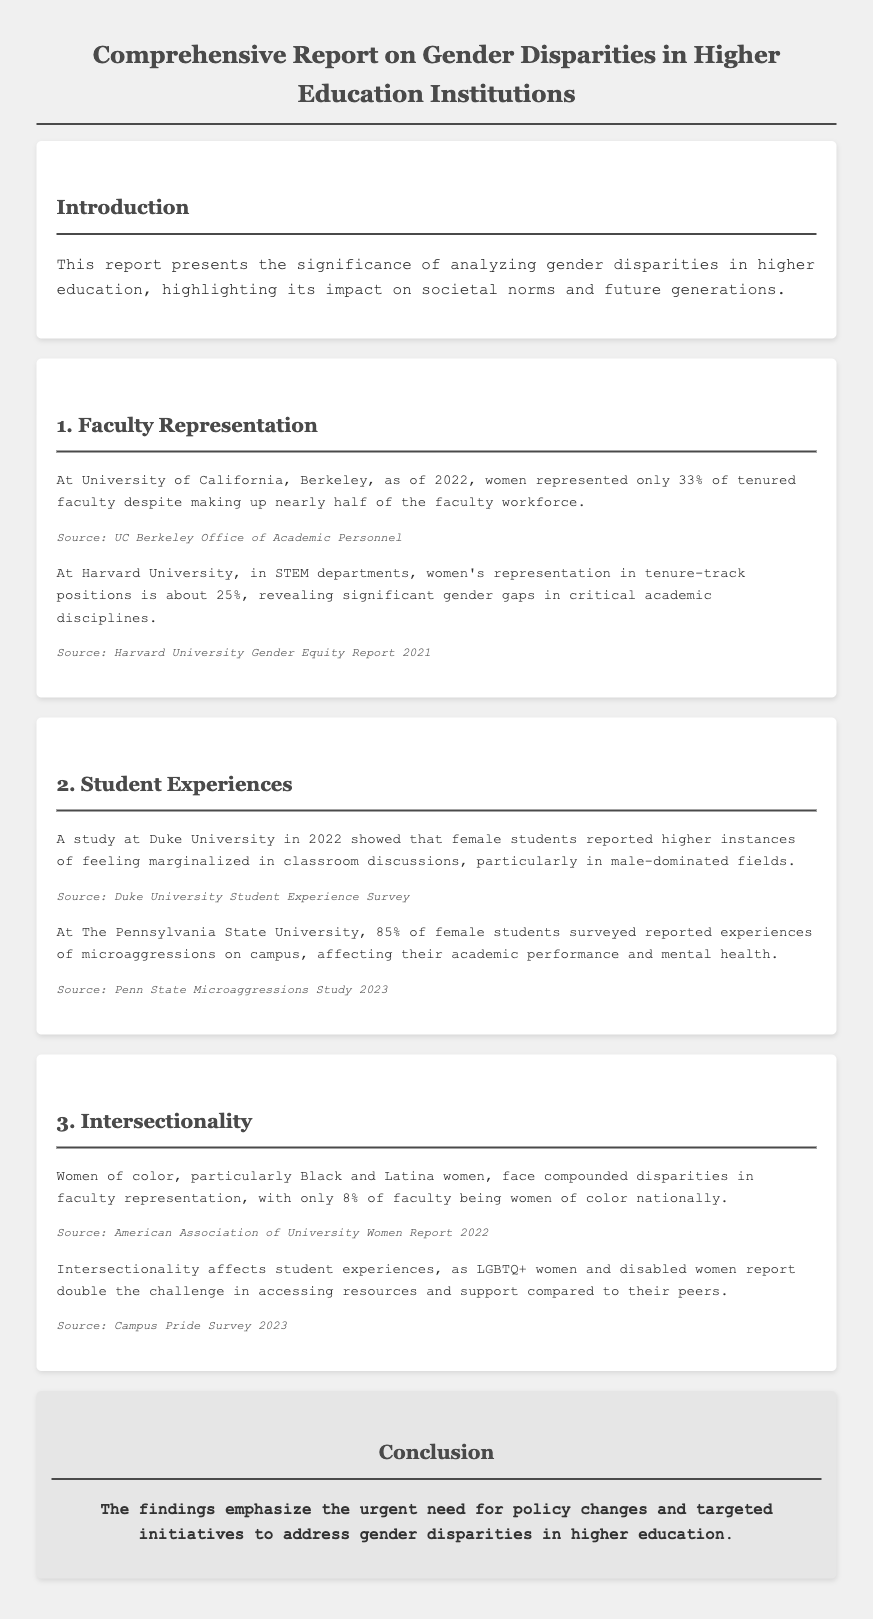What percentage of tenured faculty at UC Berkeley are women? The document states that women represented only 33% of tenured faculty at UC Berkeley.
Answer: 33% What is the representation of women in tenure-track positions in STEM at Harvard? It is mentioned that women's representation in tenure-track positions in STEM departments at Harvard is about 25%.
Answer: 25% What percentage of female students at Penn State reported experiences of microaggressions? The report indicates that 85% of female students surveyed at Penn State reported experiences of microaggressions.
Answer: 85% What compound percentage of faculty nationally are women of color? The document states that only 8% of faculty being women of color nationally.
Answer: 8% Which group of women faces double the challenge in accessing resources and support? The report identifies LGBTQ+ women and disabled women as facing double the challenge in accessing resources and support.
Answer: LGBTQ+ women and disabled women What impact do higher instances of feeling marginalized have on female students according to the Duke University study? The document suggests that this feeling affects female students’ experiences in classroom discussions, especially in male-dominated fields.
Answer: Classroom discussions What urgent need does the conclusion emphasize? The conclusion emphasizes the urgent need for policy changes and targeted initiatives to address gender disparities in higher education.
Answer: Policy changes 